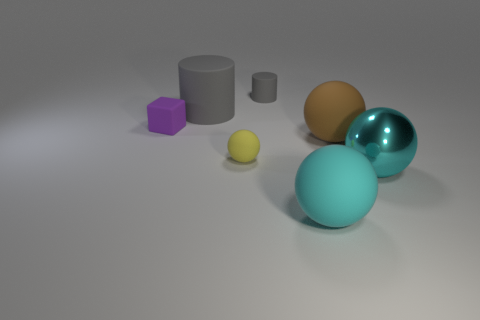Are there any other things that have the same color as the block?
Offer a terse response. No. Is there a brown ball in front of the rubber ball that is to the left of the big rubber ball in front of the metal ball?
Your answer should be compact. No. What is the color of the metallic thing?
Make the answer very short. Cyan. There is a cube; are there any small gray things in front of it?
Keep it short and to the point. No. Does the big cyan matte thing have the same shape as the big object that is to the right of the brown rubber sphere?
Your answer should be compact. Yes. How many other things are there of the same material as the big brown object?
Offer a terse response. 5. What is the color of the tiny rubber sphere on the left side of the gray object that is behind the gray cylinder left of the tiny yellow thing?
Give a very brief answer. Yellow. There is a cyan thing behind the big cyan thing in front of the cyan metal object; what is its shape?
Your response must be concise. Sphere. Are there more metallic things to the right of the small purple object than small brown cubes?
Offer a very short reply. Yes. Does the tiny rubber thing that is behind the tiny cube have the same shape as the large gray rubber object?
Your answer should be very brief. Yes. 